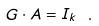Convert formula to latex. <formula><loc_0><loc_0><loc_500><loc_500>G \cdot A = I _ { k } \ .</formula> 